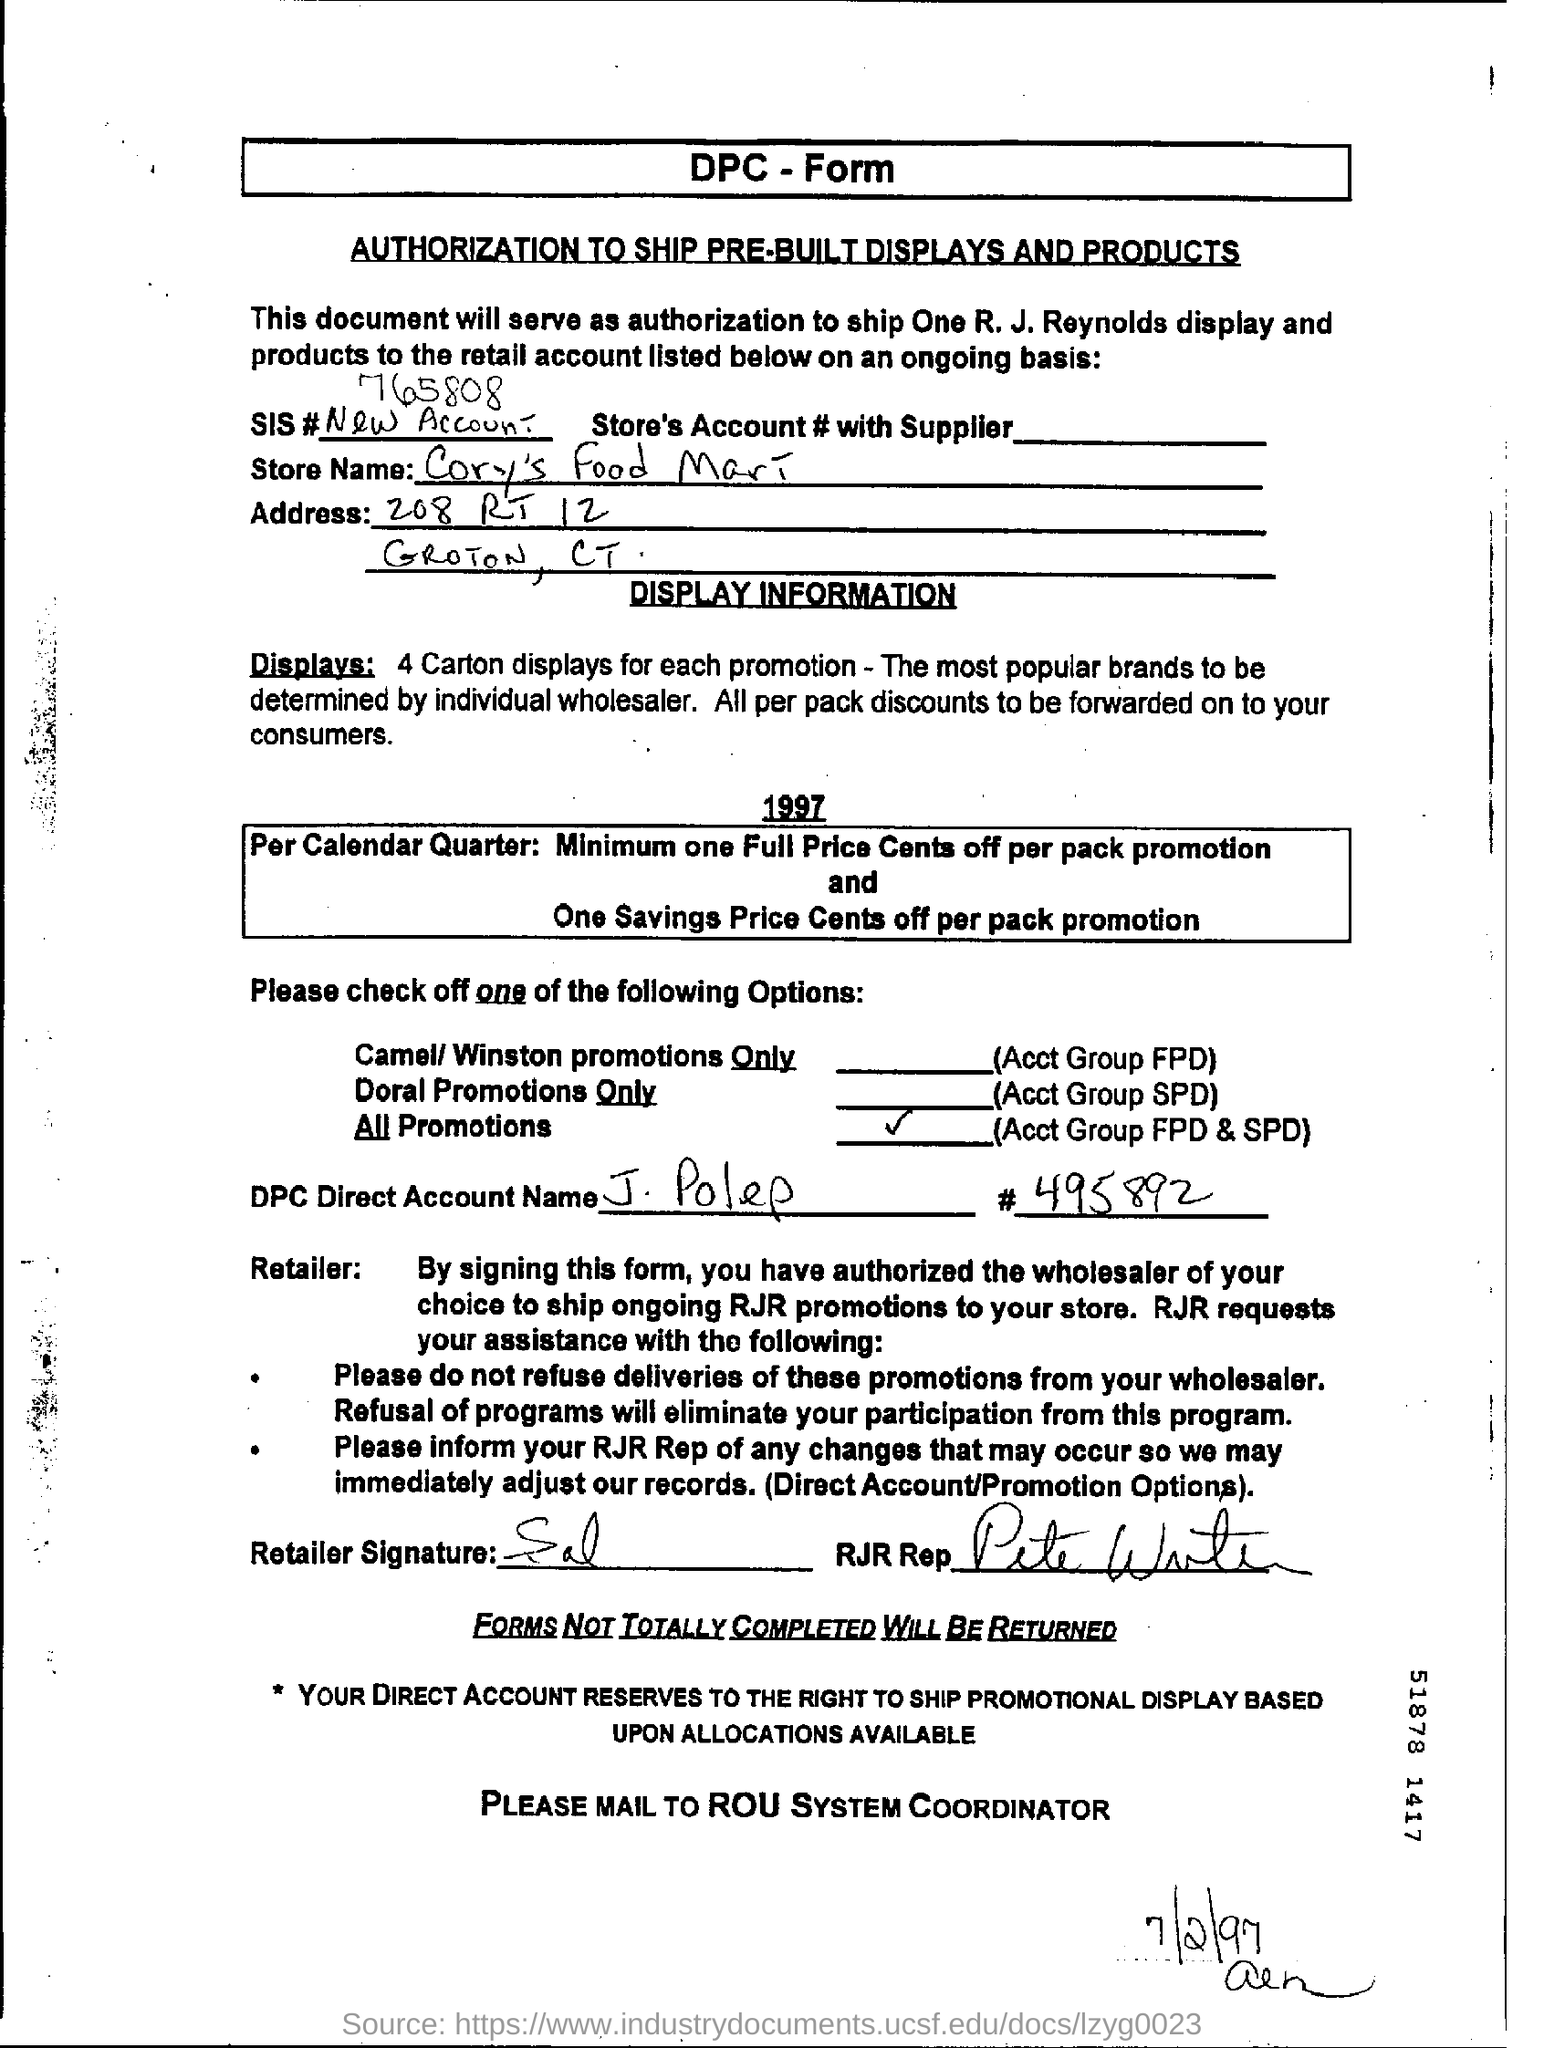What is the DPC Direct Account name?
Keep it short and to the point. J. Polep. What is the SIS Number ?
Your answer should be compact. 765808. What is the DPC Direct Account Name ?
Offer a very short reply. J. Polep. What is the date mentioned in the bottom of the document ?
Your answer should be very brief. 7/2/97. 